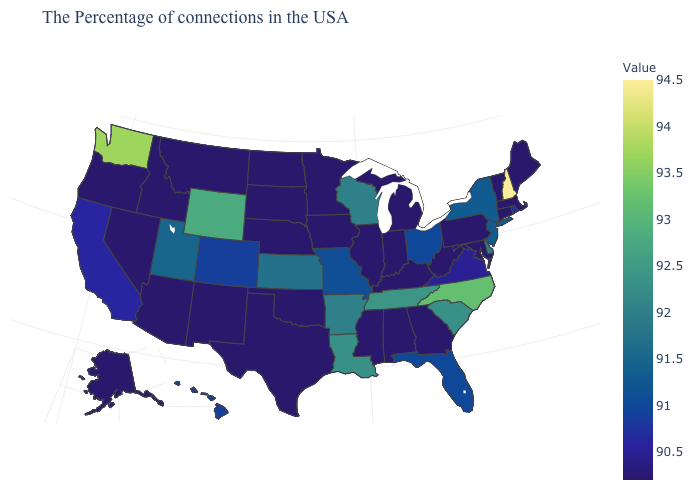Which states have the highest value in the USA?
Give a very brief answer. New Hampshire. Does Kansas have the highest value in the USA?
Quick response, please. No. Which states have the lowest value in the USA?
Quick response, please. Maine, Massachusetts, Vermont, Connecticut, Maryland, Pennsylvania, West Virginia, Georgia, Michigan, Kentucky, Indiana, Alabama, Illinois, Mississippi, Minnesota, Iowa, Nebraska, Oklahoma, Texas, South Dakota, North Dakota, New Mexico, Montana, Arizona, Idaho, Nevada, Oregon, Alaska. Among the states that border Missouri , which have the highest value?
Concise answer only. Tennessee. 